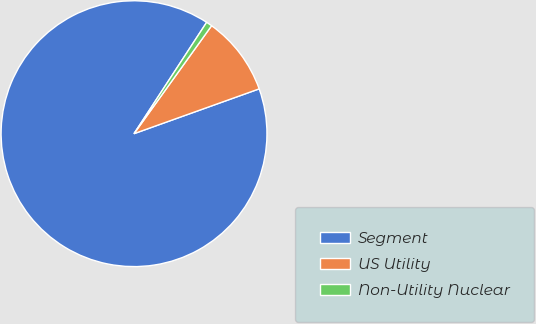Convert chart. <chart><loc_0><loc_0><loc_500><loc_500><pie_chart><fcel>Segment<fcel>US Utility<fcel>Non-Utility Nuclear<nl><fcel>89.67%<fcel>9.61%<fcel>0.72%<nl></chart> 